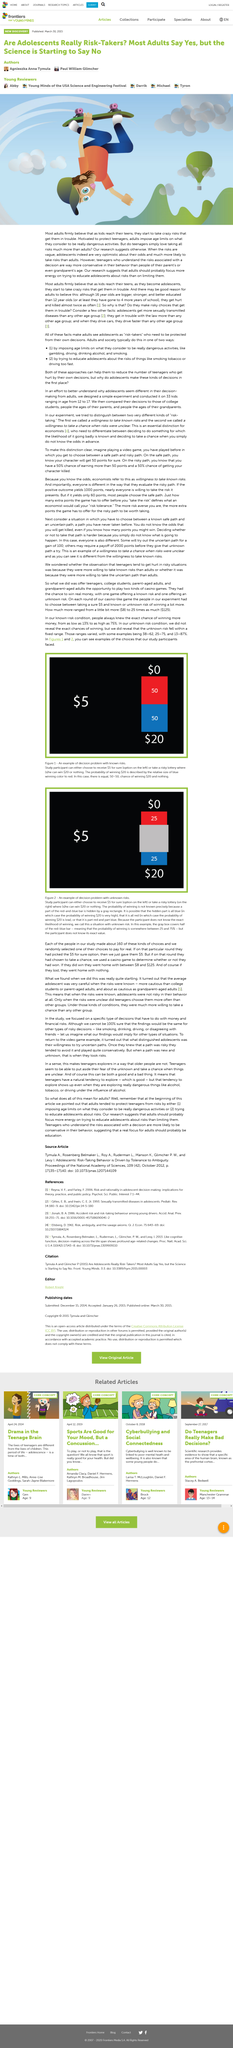List a handful of essential elements in this visual. Yes, explaining the risks in detail to teenagers is likely to make them more cautious and conservative than their parents. Teenagers are more likely to take risks when the risks are vague. 